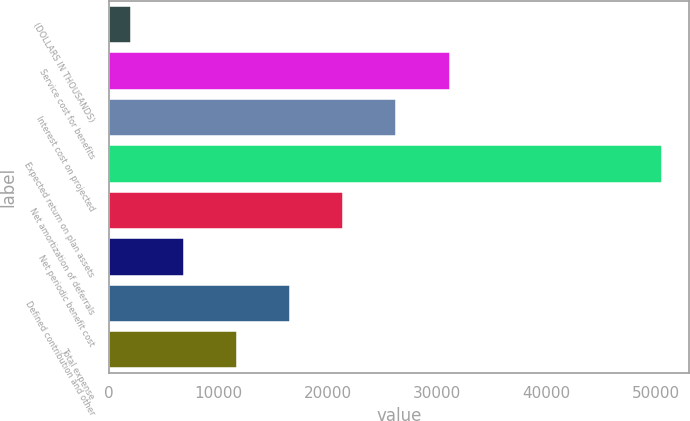Convert chart. <chart><loc_0><loc_0><loc_500><loc_500><bar_chart><fcel>(DOLLARS IN THOUSANDS)<fcel>Service cost for benefits<fcel>Interest cost on projected<fcel>Expected return on plan assets<fcel>Net amortization of deferrals<fcel>Net periodic benefit cost<fcel>Defined contribution and other<fcel>Total expense<nl><fcel>2018<fcel>31134.8<fcel>26282<fcel>50546<fcel>21429.2<fcel>6870.8<fcel>16576.4<fcel>11723.6<nl></chart> 